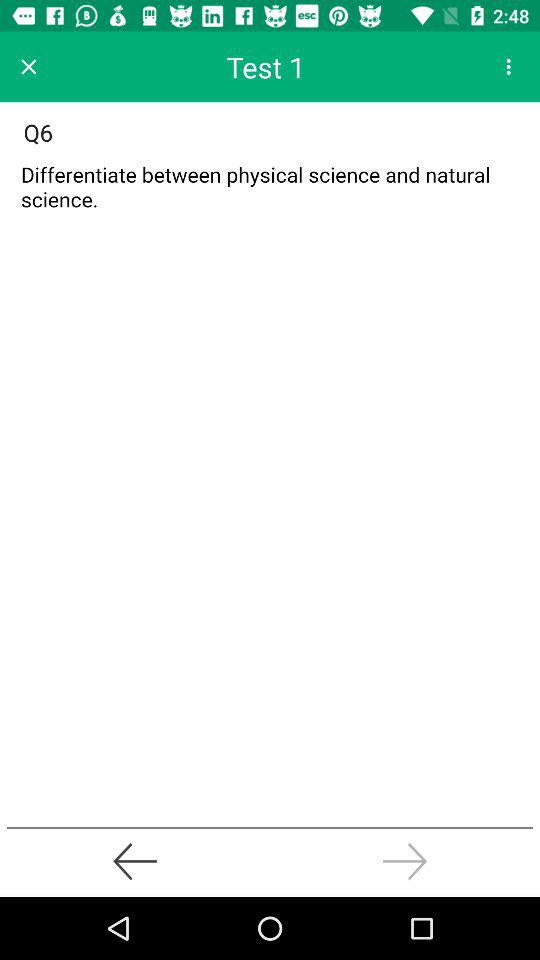At which question are we right now? You are right now at the sixth question. 